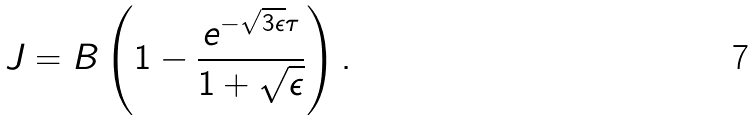Convert formula to latex. <formula><loc_0><loc_0><loc_500><loc_500>J = B \left ( 1 - \frac { e ^ { - \sqrt { 3 \epsilon } \tau } } { 1 + \sqrt { \epsilon } } \right ) .</formula> 